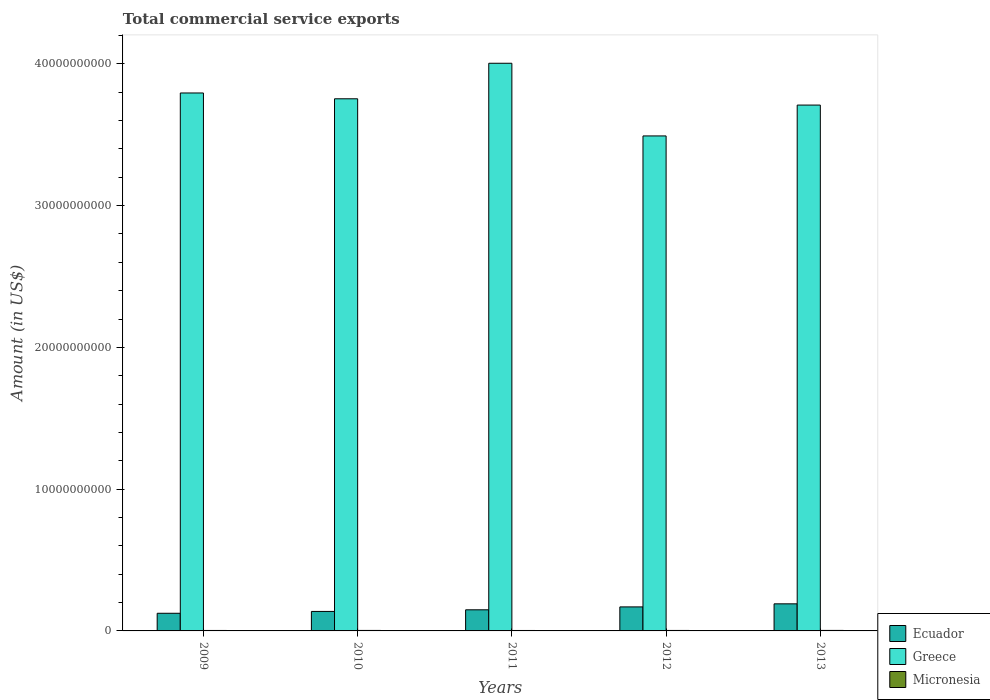How many different coloured bars are there?
Keep it short and to the point. 3. How many groups of bars are there?
Ensure brevity in your answer.  5. How many bars are there on the 1st tick from the left?
Keep it short and to the point. 3. How many bars are there on the 3rd tick from the right?
Offer a terse response. 3. In how many cases, is the number of bars for a given year not equal to the number of legend labels?
Offer a terse response. 0. What is the total commercial service exports in Micronesia in 2009?
Your answer should be compact. 3.21e+07. Across all years, what is the maximum total commercial service exports in Micronesia?
Provide a short and direct response. 3.59e+07. Across all years, what is the minimum total commercial service exports in Greece?
Offer a very short reply. 3.49e+1. In which year was the total commercial service exports in Greece maximum?
Your answer should be compact. 2011. In which year was the total commercial service exports in Greece minimum?
Give a very brief answer. 2012. What is the total total commercial service exports in Greece in the graph?
Make the answer very short. 1.88e+11. What is the difference between the total commercial service exports in Ecuador in 2009 and that in 2010?
Make the answer very short. -1.31e+08. What is the difference between the total commercial service exports in Ecuador in 2010 and the total commercial service exports in Greece in 2012?
Offer a very short reply. -3.35e+1. What is the average total commercial service exports in Greece per year?
Provide a short and direct response. 3.75e+1. In the year 2012, what is the difference between the total commercial service exports in Greece and total commercial service exports in Micronesia?
Offer a very short reply. 3.49e+1. What is the ratio of the total commercial service exports in Micronesia in 2011 to that in 2013?
Your response must be concise. 0.87. What is the difference between the highest and the second highest total commercial service exports in Micronesia?
Provide a succinct answer. 9.83e+05. What is the difference between the highest and the lowest total commercial service exports in Ecuador?
Provide a short and direct response. 6.66e+08. Is the sum of the total commercial service exports in Greece in 2010 and 2011 greater than the maximum total commercial service exports in Micronesia across all years?
Provide a short and direct response. Yes. What does the 3rd bar from the left in 2011 represents?
Your answer should be very brief. Micronesia. What does the 1st bar from the right in 2010 represents?
Give a very brief answer. Micronesia. How many bars are there?
Provide a succinct answer. 15. Are all the bars in the graph horizontal?
Offer a very short reply. No. How many years are there in the graph?
Make the answer very short. 5. What is the difference between two consecutive major ticks on the Y-axis?
Provide a short and direct response. 1.00e+1. Are the values on the major ticks of Y-axis written in scientific E-notation?
Your answer should be very brief. No. What is the title of the graph?
Offer a very short reply. Total commercial service exports. What is the Amount (in US$) in Ecuador in 2009?
Ensure brevity in your answer.  1.24e+09. What is the Amount (in US$) of Greece in 2009?
Provide a succinct answer. 3.79e+1. What is the Amount (in US$) in Micronesia in 2009?
Give a very brief answer. 3.21e+07. What is the Amount (in US$) in Ecuador in 2010?
Your response must be concise. 1.38e+09. What is the Amount (in US$) in Greece in 2010?
Offer a terse response. 3.75e+1. What is the Amount (in US$) in Micronesia in 2010?
Offer a terse response. 3.50e+07. What is the Amount (in US$) of Ecuador in 2011?
Your response must be concise. 1.49e+09. What is the Amount (in US$) of Greece in 2011?
Provide a succinct answer. 4.00e+1. What is the Amount (in US$) of Micronesia in 2011?
Keep it short and to the point. 3.13e+07. What is the Amount (in US$) of Ecuador in 2012?
Keep it short and to the point. 1.69e+09. What is the Amount (in US$) of Greece in 2012?
Your answer should be very brief. 3.49e+1. What is the Amount (in US$) of Micronesia in 2012?
Provide a short and direct response. 3.40e+07. What is the Amount (in US$) of Ecuador in 2013?
Ensure brevity in your answer.  1.91e+09. What is the Amount (in US$) of Greece in 2013?
Provide a short and direct response. 3.71e+1. What is the Amount (in US$) of Micronesia in 2013?
Ensure brevity in your answer.  3.59e+07. Across all years, what is the maximum Amount (in US$) in Ecuador?
Your answer should be very brief. 1.91e+09. Across all years, what is the maximum Amount (in US$) of Greece?
Your response must be concise. 4.00e+1. Across all years, what is the maximum Amount (in US$) of Micronesia?
Provide a succinct answer. 3.59e+07. Across all years, what is the minimum Amount (in US$) of Ecuador?
Your response must be concise. 1.24e+09. Across all years, what is the minimum Amount (in US$) of Greece?
Your answer should be compact. 3.49e+1. Across all years, what is the minimum Amount (in US$) of Micronesia?
Keep it short and to the point. 3.13e+07. What is the total Amount (in US$) in Ecuador in the graph?
Ensure brevity in your answer.  7.72e+09. What is the total Amount (in US$) in Greece in the graph?
Provide a succinct answer. 1.88e+11. What is the total Amount (in US$) in Micronesia in the graph?
Offer a very short reply. 1.68e+08. What is the difference between the Amount (in US$) of Ecuador in 2009 and that in 2010?
Ensure brevity in your answer.  -1.31e+08. What is the difference between the Amount (in US$) in Greece in 2009 and that in 2010?
Offer a terse response. 4.10e+08. What is the difference between the Amount (in US$) in Micronesia in 2009 and that in 2010?
Provide a short and direct response. -2.88e+06. What is the difference between the Amount (in US$) in Ecuador in 2009 and that in 2011?
Ensure brevity in your answer.  -2.45e+08. What is the difference between the Amount (in US$) of Greece in 2009 and that in 2011?
Provide a short and direct response. -2.10e+09. What is the difference between the Amount (in US$) in Micronesia in 2009 and that in 2011?
Ensure brevity in your answer.  8.24e+05. What is the difference between the Amount (in US$) of Ecuador in 2009 and that in 2012?
Offer a terse response. -4.49e+08. What is the difference between the Amount (in US$) of Greece in 2009 and that in 2012?
Offer a very short reply. 3.03e+09. What is the difference between the Amount (in US$) of Micronesia in 2009 and that in 2012?
Offer a very short reply. -1.88e+06. What is the difference between the Amount (in US$) in Ecuador in 2009 and that in 2013?
Keep it short and to the point. -6.66e+08. What is the difference between the Amount (in US$) of Greece in 2009 and that in 2013?
Provide a short and direct response. 8.53e+08. What is the difference between the Amount (in US$) in Micronesia in 2009 and that in 2013?
Your answer should be compact. -3.86e+06. What is the difference between the Amount (in US$) in Ecuador in 2010 and that in 2011?
Make the answer very short. -1.14e+08. What is the difference between the Amount (in US$) in Greece in 2010 and that in 2011?
Give a very brief answer. -2.51e+09. What is the difference between the Amount (in US$) of Micronesia in 2010 and that in 2011?
Your answer should be compact. 3.70e+06. What is the difference between the Amount (in US$) in Ecuador in 2010 and that in 2012?
Ensure brevity in your answer.  -3.19e+08. What is the difference between the Amount (in US$) of Greece in 2010 and that in 2012?
Your answer should be compact. 2.62e+09. What is the difference between the Amount (in US$) in Micronesia in 2010 and that in 2012?
Your answer should be very brief. 9.99e+05. What is the difference between the Amount (in US$) of Ecuador in 2010 and that in 2013?
Your response must be concise. -5.36e+08. What is the difference between the Amount (in US$) of Greece in 2010 and that in 2013?
Provide a succinct answer. 4.43e+08. What is the difference between the Amount (in US$) in Micronesia in 2010 and that in 2013?
Provide a succinct answer. -9.83e+05. What is the difference between the Amount (in US$) in Ecuador in 2011 and that in 2012?
Offer a very short reply. -2.04e+08. What is the difference between the Amount (in US$) in Greece in 2011 and that in 2012?
Give a very brief answer. 5.13e+09. What is the difference between the Amount (in US$) of Micronesia in 2011 and that in 2012?
Provide a succinct answer. -2.70e+06. What is the difference between the Amount (in US$) of Ecuador in 2011 and that in 2013?
Provide a short and direct response. -4.21e+08. What is the difference between the Amount (in US$) of Greece in 2011 and that in 2013?
Your answer should be very brief. 2.95e+09. What is the difference between the Amount (in US$) of Micronesia in 2011 and that in 2013?
Make the answer very short. -4.68e+06. What is the difference between the Amount (in US$) in Ecuador in 2012 and that in 2013?
Make the answer very short. -2.17e+08. What is the difference between the Amount (in US$) in Greece in 2012 and that in 2013?
Ensure brevity in your answer.  -2.18e+09. What is the difference between the Amount (in US$) in Micronesia in 2012 and that in 2013?
Ensure brevity in your answer.  -1.98e+06. What is the difference between the Amount (in US$) in Ecuador in 2009 and the Amount (in US$) in Greece in 2010?
Offer a terse response. -3.63e+1. What is the difference between the Amount (in US$) of Ecuador in 2009 and the Amount (in US$) of Micronesia in 2010?
Provide a short and direct response. 1.21e+09. What is the difference between the Amount (in US$) in Greece in 2009 and the Amount (in US$) in Micronesia in 2010?
Make the answer very short. 3.79e+1. What is the difference between the Amount (in US$) of Ecuador in 2009 and the Amount (in US$) of Greece in 2011?
Make the answer very short. -3.88e+1. What is the difference between the Amount (in US$) of Ecuador in 2009 and the Amount (in US$) of Micronesia in 2011?
Ensure brevity in your answer.  1.21e+09. What is the difference between the Amount (in US$) of Greece in 2009 and the Amount (in US$) of Micronesia in 2011?
Your response must be concise. 3.79e+1. What is the difference between the Amount (in US$) in Ecuador in 2009 and the Amount (in US$) in Greece in 2012?
Offer a terse response. -3.37e+1. What is the difference between the Amount (in US$) in Ecuador in 2009 and the Amount (in US$) in Micronesia in 2012?
Offer a very short reply. 1.21e+09. What is the difference between the Amount (in US$) in Greece in 2009 and the Amount (in US$) in Micronesia in 2012?
Your answer should be very brief. 3.79e+1. What is the difference between the Amount (in US$) in Ecuador in 2009 and the Amount (in US$) in Greece in 2013?
Your answer should be compact. -3.58e+1. What is the difference between the Amount (in US$) of Ecuador in 2009 and the Amount (in US$) of Micronesia in 2013?
Your answer should be very brief. 1.21e+09. What is the difference between the Amount (in US$) in Greece in 2009 and the Amount (in US$) in Micronesia in 2013?
Provide a short and direct response. 3.79e+1. What is the difference between the Amount (in US$) of Ecuador in 2010 and the Amount (in US$) of Greece in 2011?
Provide a short and direct response. -3.87e+1. What is the difference between the Amount (in US$) in Ecuador in 2010 and the Amount (in US$) in Micronesia in 2011?
Keep it short and to the point. 1.34e+09. What is the difference between the Amount (in US$) in Greece in 2010 and the Amount (in US$) in Micronesia in 2011?
Provide a succinct answer. 3.75e+1. What is the difference between the Amount (in US$) in Ecuador in 2010 and the Amount (in US$) in Greece in 2012?
Provide a short and direct response. -3.35e+1. What is the difference between the Amount (in US$) in Ecuador in 2010 and the Amount (in US$) in Micronesia in 2012?
Offer a terse response. 1.34e+09. What is the difference between the Amount (in US$) of Greece in 2010 and the Amount (in US$) of Micronesia in 2012?
Provide a short and direct response. 3.75e+1. What is the difference between the Amount (in US$) in Ecuador in 2010 and the Amount (in US$) in Greece in 2013?
Keep it short and to the point. -3.57e+1. What is the difference between the Amount (in US$) in Ecuador in 2010 and the Amount (in US$) in Micronesia in 2013?
Keep it short and to the point. 1.34e+09. What is the difference between the Amount (in US$) in Greece in 2010 and the Amount (in US$) in Micronesia in 2013?
Provide a succinct answer. 3.75e+1. What is the difference between the Amount (in US$) of Ecuador in 2011 and the Amount (in US$) of Greece in 2012?
Provide a succinct answer. -3.34e+1. What is the difference between the Amount (in US$) in Ecuador in 2011 and the Amount (in US$) in Micronesia in 2012?
Make the answer very short. 1.46e+09. What is the difference between the Amount (in US$) of Greece in 2011 and the Amount (in US$) of Micronesia in 2012?
Make the answer very short. 4.00e+1. What is the difference between the Amount (in US$) in Ecuador in 2011 and the Amount (in US$) in Greece in 2013?
Your response must be concise. -3.56e+1. What is the difference between the Amount (in US$) in Ecuador in 2011 and the Amount (in US$) in Micronesia in 2013?
Offer a terse response. 1.45e+09. What is the difference between the Amount (in US$) of Greece in 2011 and the Amount (in US$) of Micronesia in 2013?
Keep it short and to the point. 4.00e+1. What is the difference between the Amount (in US$) in Ecuador in 2012 and the Amount (in US$) in Greece in 2013?
Your answer should be compact. -3.54e+1. What is the difference between the Amount (in US$) in Ecuador in 2012 and the Amount (in US$) in Micronesia in 2013?
Offer a very short reply. 1.66e+09. What is the difference between the Amount (in US$) in Greece in 2012 and the Amount (in US$) in Micronesia in 2013?
Provide a short and direct response. 3.49e+1. What is the average Amount (in US$) in Ecuador per year?
Offer a terse response. 1.54e+09. What is the average Amount (in US$) of Greece per year?
Offer a terse response. 3.75e+1. What is the average Amount (in US$) of Micronesia per year?
Ensure brevity in your answer.  3.36e+07. In the year 2009, what is the difference between the Amount (in US$) in Ecuador and Amount (in US$) in Greece?
Keep it short and to the point. -3.67e+1. In the year 2009, what is the difference between the Amount (in US$) of Ecuador and Amount (in US$) of Micronesia?
Provide a succinct answer. 1.21e+09. In the year 2009, what is the difference between the Amount (in US$) of Greece and Amount (in US$) of Micronesia?
Ensure brevity in your answer.  3.79e+1. In the year 2010, what is the difference between the Amount (in US$) of Ecuador and Amount (in US$) of Greece?
Your answer should be very brief. -3.62e+1. In the year 2010, what is the difference between the Amount (in US$) of Ecuador and Amount (in US$) of Micronesia?
Your answer should be very brief. 1.34e+09. In the year 2010, what is the difference between the Amount (in US$) in Greece and Amount (in US$) in Micronesia?
Your answer should be compact. 3.75e+1. In the year 2011, what is the difference between the Amount (in US$) of Ecuador and Amount (in US$) of Greece?
Your answer should be compact. -3.86e+1. In the year 2011, what is the difference between the Amount (in US$) in Ecuador and Amount (in US$) in Micronesia?
Your answer should be compact. 1.46e+09. In the year 2011, what is the difference between the Amount (in US$) in Greece and Amount (in US$) in Micronesia?
Provide a short and direct response. 4.00e+1. In the year 2012, what is the difference between the Amount (in US$) in Ecuador and Amount (in US$) in Greece?
Your response must be concise. -3.32e+1. In the year 2012, what is the difference between the Amount (in US$) in Ecuador and Amount (in US$) in Micronesia?
Ensure brevity in your answer.  1.66e+09. In the year 2012, what is the difference between the Amount (in US$) in Greece and Amount (in US$) in Micronesia?
Give a very brief answer. 3.49e+1. In the year 2013, what is the difference between the Amount (in US$) of Ecuador and Amount (in US$) of Greece?
Keep it short and to the point. -3.52e+1. In the year 2013, what is the difference between the Amount (in US$) of Ecuador and Amount (in US$) of Micronesia?
Provide a short and direct response. 1.88e+09. In the year 2013, what is the difference between the Amount (in US$) of Greece and Amount (in US$) of Micronesia?
Your answer should be compact. 3.71e+1. What is the ratio of the Amount (in US$) of Ecuador in 2009 to that in 2010?
Give a very brief answer. 0.91. What is the ratio of the Amount (in US$) of Greece in 2009 to that in 2010?
Give a very brief answer. 1.01. What is the ratio of the Amount (in US$) in Micronesia in 2009 to that in 2010?
Provide a succinct answer. 0.92. What is the ratio of the Amount (in US$) of Ecuador in 2009 to that in 2011?
Provide a succinct answer. 0.84. What is the ratio of the Amount (in US$) in Greece in 2009 to that in 2011?
Your answer should be compact. 0.95. What is the ratio of the Amount (in US$) in Micronesia in 2009 to that in 2011?
Provide a short and direct response. 1.03. What is the ratio of the Amount (in US$) of Ecuador in 2009 to that in 2012?
Your answer should be compact. 0.73. What is the ratio of the Amount (in US$) of Greece in 2009 to that in 2012?
Ensure brevity in your answer.  1.09. What is the ratio of the Amount (in US$) in Micronesia in 2009 to that in 2012?
Offer a terse response. 0.94. What is the ratio of the Amount (in US$) of Ecuador in 2009 to that in 2013?
Your answer should be compact. 0.65. What is the ratio of the Amount (in US$) of Micronesia in 2009 to that in 2013?
Offer a terse response. 0.89. What is the ratio of the Amount (in US$) of Ecuador in 2010 to that in 2011?
Offer a very short reply. 0.92. What is the ratio of the Amount (in US$) of Greece in 2010 to that in 2011?
Give a very brief answer. 0.94. What is the ratio of the Amount (in US$) of Micronesia in 2010 to that in 2011?
Provide a short and direct response. 1.12. What is the ratio of the Amount (in US$) of Ecuador in 2010 to that in 2012?
Make the answer very short. 0.81. What is the ratio of the Amount (in US$) in Greece in 2010 to that in 2012?
Offer a very short reply. 1.07. What is the ratio of the Amount (in US$) of Micronesia in 2010 to that in 2012?
Give a very brief answer. 1.03. What is the ratio of the Amount (in US$) in Ecuador in 2010 to that in 2013?
Make the answer very short. 0.72. What is the ratio of the Amount (in US$) in Greece in 2010 to that in 2013?
Offer a very short reply. 1.01. What is the ratio of the Amount (in US$) of Micronesia in 2010 to that in 2013?
Ensure brevity in your answer.  0.97. What is the ratio of the Amount (in US$) in Ecuador in 2011 to that in 2012?
Your answer should be compact. 0.88. What is the ratio of the Amount (in US$) in Greece in 2011 to that in 2012?
Offer a very short reply. 1.15. What is the ratio of the Amount (in US$) of Micronesia in 2011 to that in 2012?
Give a very brief answer. 0.92. What is the ratio of the Amount (in US$) in Ecuador in 2011 to that in 2013?
Make the answer very short. 0.78. What is the ratio of the Amount (in US$) of Greece in 2011 to that in 2013?
Your response must be concise. 1.08. What is the ratio of the Amount (in US$) of Micronesia in 2011 to that in 2013?
Ensure brevity in your answer.  0.87. What is the ratio of the Amount (in US$) of Ecuador in 2012 to that in 2013?
Make the answer very short. 0.89. What is the ratio of the Amount (in US$) of Greece in 2012 to that in 2013?
Ensure brevity in your answer.  0.94. What is the ratio of the Amount (in US$) in Micronesia in 2012 to that in 2013?
Give a very brief answer. 0.94. What is the difference between the highest and the second highest Amount (in US$) in Ecuador?
Your answer should be compact. 2.17e+08. What is the difference between the highest and the second highest Amount (in US$) in Greece?
Offer a very short reply. 2.10e+09. What is the difference between the highest and the second highest Amount (in US$) in Micronesia?
Your answer should be very brief. 9.83e+05. What is the difference between the highest and the lowest Amount (in US$) of Ecuador?
Make the answer very short. 6.66e+08. What is the difference between the highest and the lowest Amount (in US$) of Greece?
Give a very brief answer. 5.13e+09. What is the difference between the highest and the lowest Amount (in US$) in Micronesia?
Your response must be concise. 4.68e+06. 